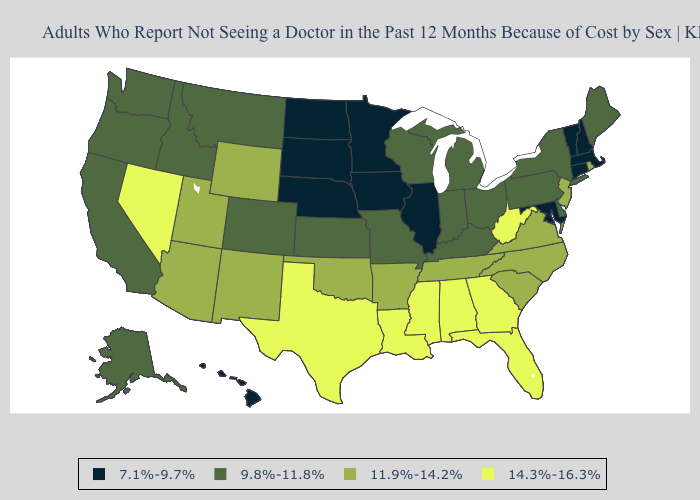What is the value of Louisiana?
Answer briefly. 14.3%-16.3%. What is the value of Connecticut?
Write a very short answer. 7.1%-9.7%. Does Wyoming have the lowest value in the USA?
Give a very brief answer. No. Name the states that have a value in the range 14.3%-16.3%?
Short answer required. Alabama, Florida, Georgia, Louisiana, Mississippi, Nevada, Texas, West Virginia. Does the first symbol in the legend represent the smallest category?
Answer briefly. Yes. Among the states that border North Dakota , does Minnesota have the lowest value?
Keep it brief. Yes. What is the lowest value in the MidWest?
Give a very brief answer. 7.1%-9.7%. Name the states that have a value in the range 14.3%-16.3%?
Keep it brief. Alabama, Florida, Georgia, Louisiana, Mississippi, Nevada, Texas, West Virginia. Name the states that have a value in the range 11.9%-14.2%?
Short answer required. Arizona, Arkansas, New Jersey, New Mexico, North Carolina, Oklahoma, Rhode Island, South Carolina, Tennessee, Utah, Virginia, Wyoming. Name the states that have a value in the range 14.3%-16.3%?
Write a very short answer. Alabama, Florida, Georgia, Louisiana, Mississippi, Nevada, Texas, West Virginia. Name the states that have a value in the range 9.8%-11.8%?
Short answer required. Alaska, California, Colorado, Delaware, Idaho, Indiana, Kansas, Kentucky, Maine, Michigan, Missouri, Montana, New York, Ohio, Oregon, Pennsylvania, Washington, Wisconsin. Which states have the lowest value in the USA?
Short answer required. Connecticut, Hawaii, Illinois, Iowa, Maryland, Massachusetts, Minnesota, Nebraska, New Hampshire, North Dakota, South Dakota, Vermont. Name the states that have a value in the range 11.9%-14.2%?
Keep it brief. Arizona, Arkansas, New Jersey, New Mexico, North Carolina, Oklahoma, Rhode Island, South Carolina, Tennessee, Utah, Virginia, Wyoming. 